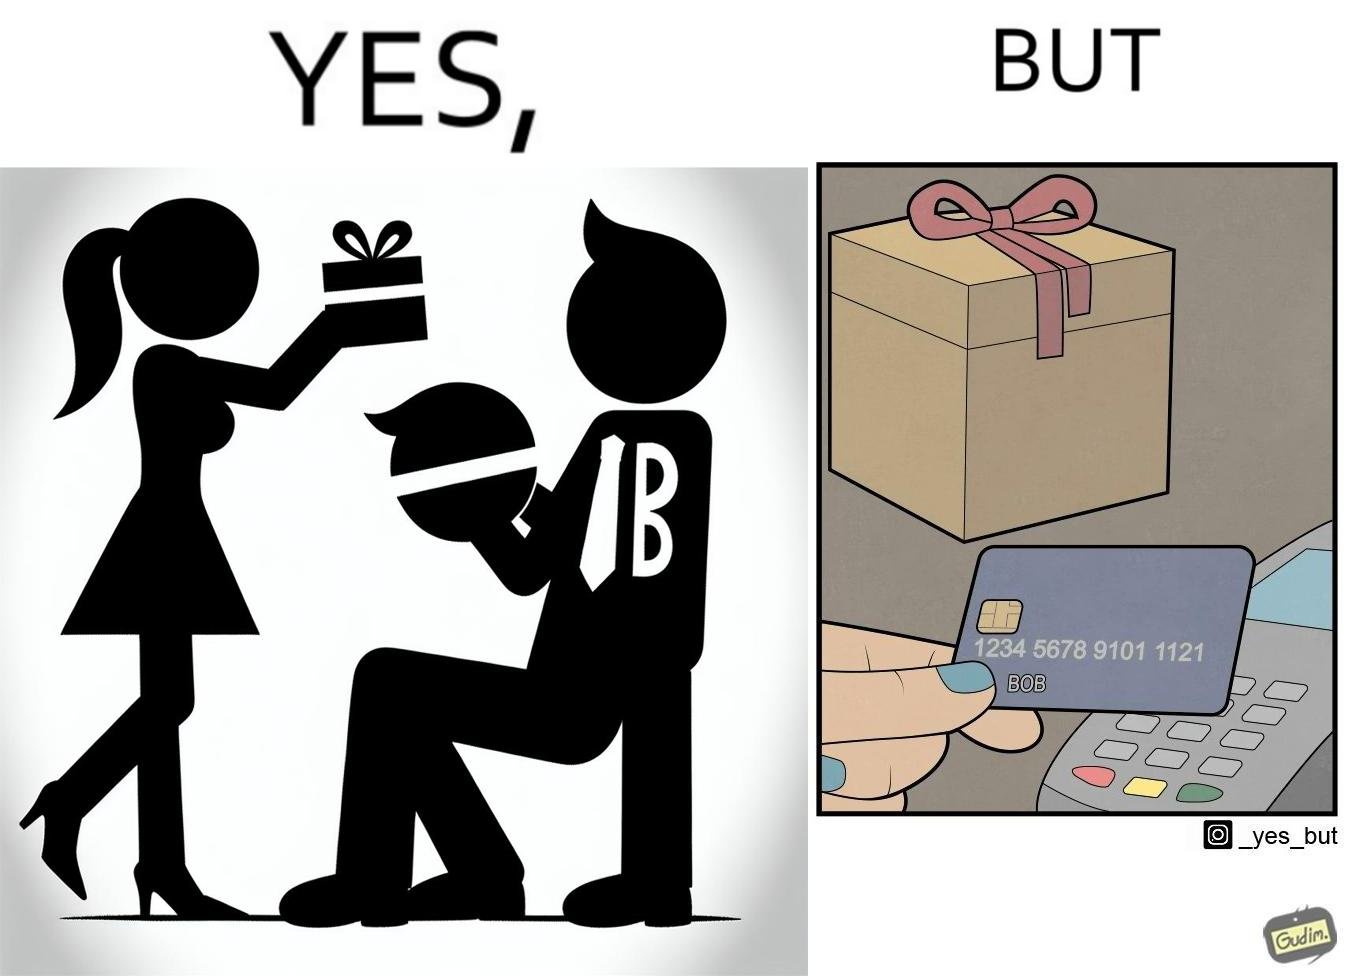What is shown in this image? The image is ironical, as a woman is gifting something to a person named Bob, while using Bob's card itself to purchase the gift. 